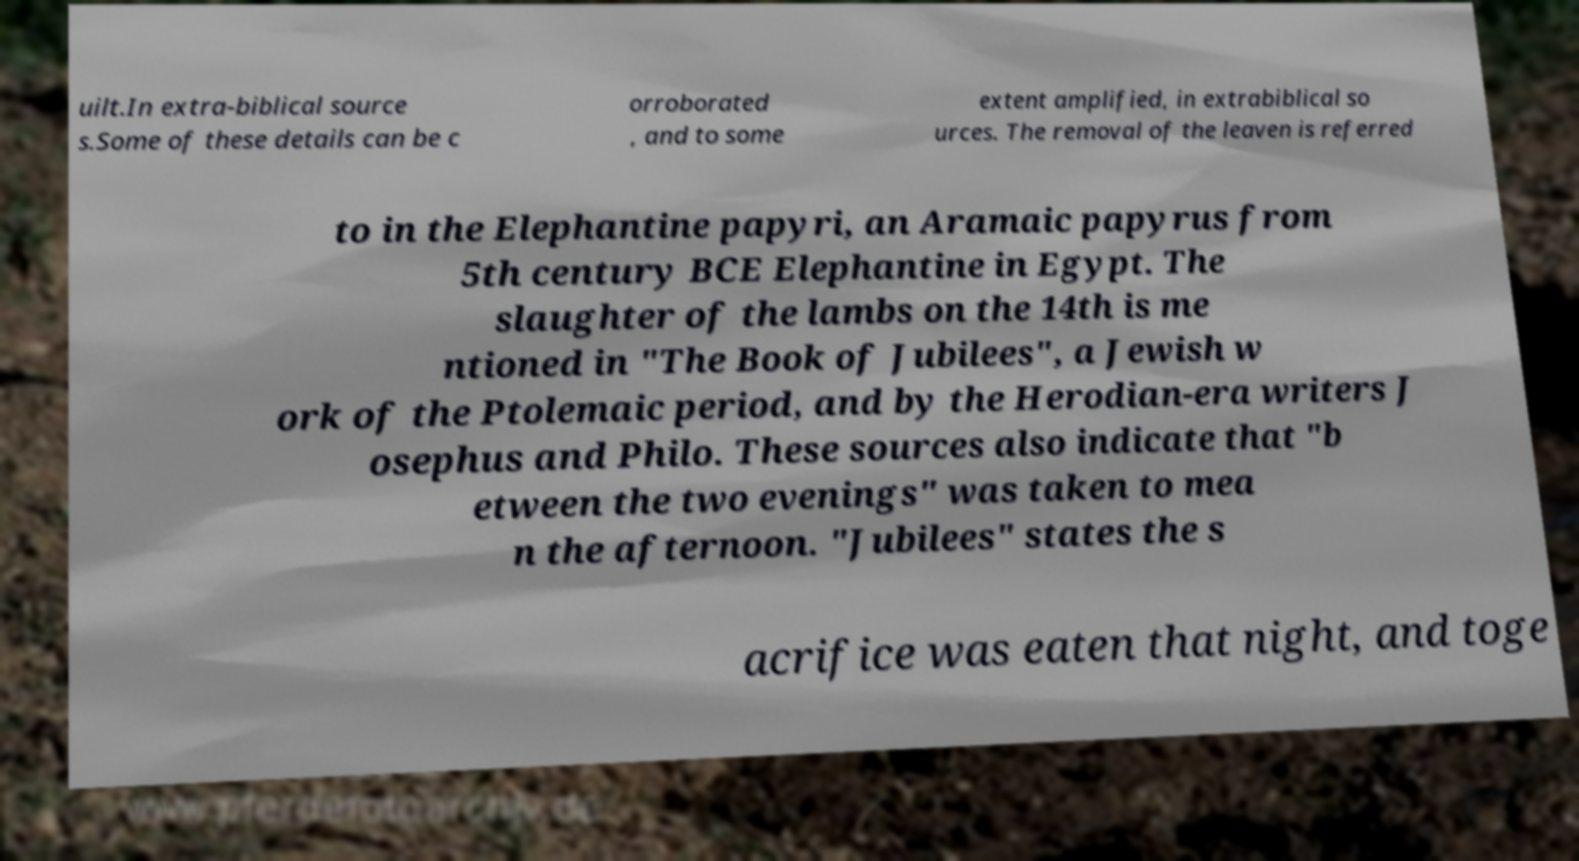I need the written content from this picture converted into text. Can you do that? uilt.In extra-biblical source s.Some of these details can be c orroborated , and to some extent amplified, in extrabiblical so urces. The removal of the leaven is referred to in the Elephantine papyri, an Aramaic papyrus from 5th century BCE Elephantine in Egypt. The slaughter of the lambs on the 14th is me ntioned in "The Book of Jubilees", a Jewish w ork of the Ptolemaic period, and by the Herodian-era writers J osephus and Philo. These sources also indicate that "b etween the two evenings" was taken to mea n the afternoon. "Jubilees" states the s acrifice was eaten that night, and toge 